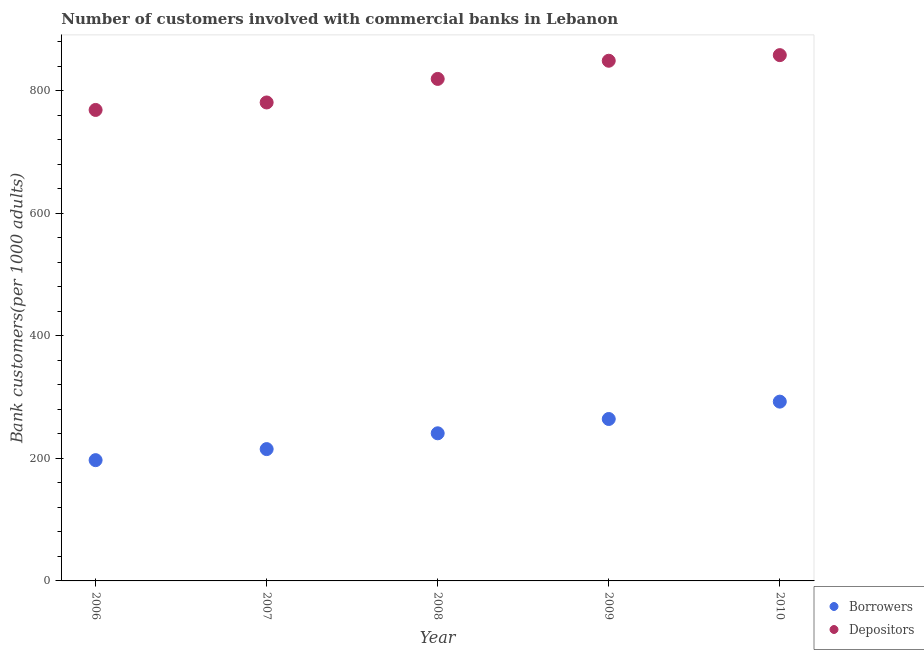Is the number of dotlines equal to the number of legend labels?
Make the answer very short. Yes. What is the number of borrowers in 2008?
Give a very brief answer. 240.91. Across all years, what is the maximum number of borrowers?
Provide a short and direct response. 292.58. Across all years, what is the minimum number of borrowers?
Offer a very short reply. 197.08. In which year was the number of depositors maximum?
Keep it short and to the point. 2010. In which year was the number of depositors minimum?
Give a very brief answer. 2006. What is the total number of borrowers in the graph?
Your answer should be very brief. 1209.93. What is the difference between the number of depositors in 2009 and that in 2010?
Your answer should be very brief. -9.17. What is the difference between the number of borrowers in 2007 and the number of depositors in 2009?
Provide a short and direct response. -633.75. What is the average number of depositors per year?
Give a very brief answer. 815.1. In the year 2006, what is the difference between the number of borrowers and number of depositors?
Offer a very short reply. -571.5. What is the ratio of the number of borrowers in 2008 to that in 2010?
Make the answer very short. 0.82. Is the number of borrowers in 2009 less than that in 2010?
Your answer should be compact. Yes. What is the difference between the highest and the second highest number of depositors?
Your response must be concise. 9.17. What is the difference between the highest and the lowest number of borrowers?
Offer a terse response. 95.5. Is the sum of the number of borrowers in 2007 and 2010 greater than the maximum number of depositors across all years?
Offer a terse response. No. Is the number of depositors strictly less than the number of borrowers over the years?
Offer a terse response. No. How many years are there in the graph?
Give a very brief answer. 5. Are the values on the major ticks of Y-axis written in scientific E-notation?
Your answer should be very brief. No. Does the graph contain grids?
Give a very brief answer. No. How many legend labels are there?
Provide a short and direct response. 2. How are the legend labels stacked?
Offer a very short reply. Vertical. What is the title of the graph?
Your answer should be compact. Number of customers involved with commercial banks in Lebanon. Does "Current education expenditure" appear as one of the legend labels in the graph?
Keep it short and to the point. No. What is the label or title of the X-axis?
Your answer should be compact. Year. What is the label or title of the Y-axis?
Give a very brief answer. Bank customers(per 1000 adults). What is the Bank customers(per 1000 adults) of Borrowers in 2006?
Provide a succinct answer. 197.08. What is the Bank customers(per 1000 adults) of Depositors in 2006?
Ensure brevity in your answer.  768.58. What is the Bank customers(per 1000 adults) of Borrowers in 2007?
Make the answer very short. 215.11. What is the Bank customers(per 1000 adults) of Depositors in 2007?
Offer a terse response. 780.78. What is the Bank customers(per 1000 adults) of Borrowers in 2008?
Provide a succinct answer. 240.91. What is the Bank customers(per 1000 adults) in Depositors in 2008?
Your answer should be compact. 819.23. What is the Bank customers(per 1000 adults) in Borrowers in 2009?
Provide a short and direct response. 264.25. What is the Bank customers(per 1000 adults) of Depositors in 2009?
Provide a short and direct response. 848.86. What is the Bank customers(per 1000 adults) in Borrowers in 2010?
Give a very brief answer. 292.58. What is the Bank customers(per 1000 adults) in Depositors in 2010?
Provide a short and direct response. 858.04. Across all years, what is the maximum Bank customers(per 1000 adults) in Borrowers?
Your response must be concise. 292.58. Across all years, what is the maximum Bank customers(per 1000 adults) of Depositors?
Ensure brevity in your answer.  858.04. Across all years, what is the minimum Bank customers(per 1000 adults) of Borrowers?
Offer a terse response. 197.08. Across all years, what is the minimum Bank customers(per 1000 adults) in Depositors?
Give a very brief answer. 768.58. What is the total Bank customers(per 1000 adults) in Borrowers in the graph?
Your response must be concise. 1209.93. What is the total Bank customers(per 1000 adults) of Depositors in the graph?
Your answer should be very brief. 4075.48. What is the difference between the Bank customers(per 1000 adults) in Borrowers in 2006 and that in 2007?
Give a very brief answer. -18.03. What is the difference between the Bank customers(per 1000 adults) in Depositors in 2006 and that in 2007?
Offer a terse response. -12.2. What is the difference between the Bank customers(per 1000 adults) in Borrowers in 2006 and that in 2008?
Make the answer very short. -43.83. What is the difference between the Bank customers(per 1000 adults) in Depositors in 2006 and that in 2008?
Your response must be concise. -50.65. What is the difference between the Bank customers(per 1000 adults) of Borrowers in 2006 and that in 2009?
Make the answer very short. -67.17. What is the difference between the Bank customers(per 1000 adults) in Depositors in 2006 and that in 2009?
Make the answer very short. -80.28. What is the difference between the Bank customers(per 1000 adults) in Borrowers in 2006 and that in 2010?
Keep it short and to the point. -95.5. What is the difference between the Bank customers(per 1000 adults) of Depositors in 2006 and that in 2010?
Offer a very short reply. -89.46. What is the difference between the Bank customers(per 1000 adults) of Borrowers in 2007 and that in 2008?
Offer a terse response. -25.79. What is the difference between the Bank customers(per 1000 adults) in Depositors in 2007 and that in 2008?
Provide a succinct answer. -38.45. What is the difference between the Bank customers(per 1000 adults) of Borrowers in 2007 and that in 2009?
Provide a short and direct response. -49.13. What is the difference between the Bank customers(per 1000 adults) in Depositors in 2007 and that in 2009?
Offer a terse response. -68.08. What is the difference between the Bank customers(per 1000 adults) of Borrowers in 2007 and that in 2010?
Offer a very short reply. -77.47. What is the difference between the Bank customers(per 1000 adults) of Depositors in 2007 and that in 2010?
Provide a short and direct response. -77.26. What is the difference between the Bank customers(per 1000 adults) of Borrowers in 2008 and that in 2009?
Keep it short and to the point. -23.34. What is the difference between the Bank customers(per 1000 adults) in Depositors in 2008 and that in 2009?
Ensure brevity in your answer.  -29.63. What is the difference between the Bank customers(per 1000 adults) in Borrowers in 2008 and that in 2010?
Offer a terse response. -51.68. What is the difference between the Bank customers(per 1000 adults) in Depositors in 2008 and that in 2010?
Your answer should be compact. -38.81. What is the difference between the Bank customers(per 1000 adults) of Borrowers in 2009 and that in 2010?
Provide a short and direct response. -28.33. What is the difference between the Bank customers(per 1000 adults) of Depositors in 2009 and that in 2010?
Make the answer very short. -9.17. What is the difference between the Bank customers(per 1000 adults) of Borrowers in 2006 and the Bank customers(per 1000 adults) of Depositors in 2007?
Your answer should be compact. -583.7. What is the difference between the Bank customers(per 1000 adults) in Borrowers in 2006 and the Bank customers(per 1000 adults) in Depositors in 2008?
Provide a succinct answer. -622.15. What is the difference between the Bank customers(per 1000 adults) of Borrowers in 2006 and the Bank customers(per 1000 adults) of Depositors in 2009?
Make the answer very short. -651.78. What is the difference between the Bank customers(per 1000 adults) in Borrowers in 2006 and the Bank customers(per 1000 adults) in Depositors in 2010?
Your answer should be very brief. -660.96. What is the difference between the Bank customers(per 1000 adults) in Borrowers in 2007 and the Bank customers(per 1000 adults) in Depositors in 2008?
Ensure brevity in your answer.  -604.11. What is the difference between the Bank customers(per 1000 adults) of Borrowers in 2007 and the Bank customers(per 1000 adults) of Depositors in 2009?
Offer a very short reply. -633.75. What is the difference between the Bank customers(per 1000 adults) of Borrowers in 2007 and the Bank customers(per 1000 adults) of Depositors in 2010?
Provide a succinct answer. -642.92. What is the difference between the Bank customers(per 1000 adults) in Borrowers in 2008 and the Bank customers(per 1000 adults) in Depositors in 2009?
Your answer should be very brief. -607.96. What is the difference between the Bank customers(per 1000 adults) of Borrowers in 2008 and the Bank customers(per 1000 adults) of Depositors in 2010?
Provide a short and direct response. -617.13. What is the difference between the Bank customers(per 1000 adults) of Borrowers in 2009 and the Bank customers(per 1000 adults) of Depositors in 2010?
Make the answer very short. -593.79. What is the average Bank customers(per 1000 adults) of Borrowers per year?
Offer a very short reply. 241.99. What is the average Bank customers(per 1000 adults) in Depositors per year?
Your answer should be compact. 815.1. In the year 2006, what is the difference between the Bank customers(per 1000 adults) of Borrowers and Bank customers(per 1000 adults) of Depositors?
Ensure brevity in your answer.  -571.5. In the year 2007, what is the difference between the Bank customers(per 1000 adults) of Borrowers and Bank customers(per 1000 adults) of Depositors?
Your answer should be very brief. -565.67. In the year 2008, what is the difference between the Bank customers(per 1000 adults) of Borrowers and Bank customers(per 1000 adults) of Depositors?
Provide a succinct answer. -578.32. In the year 2009, what is the difference between the Bank customers(per 1000 adults) in Borrowers and Bank customers(per 1000 adults) in Depositors?
Provide a succinct answer. -584.61. In the year 2010, what is the difference between the Bank customers(per 1000 adults) in Borrowers and Bank customers(per 1000 adults) in Depositors?
Ensure brevity in your answer.  -565.45. What is the ratio of the Bank customers(per 1000 adults) in Borrowers in 2006 to that in 2007?
Keep it short and to the point. 0.92. What is the ratio of the Bank customers(per 1000 adults) in Depositors in 2006 to that in 2007?
Provide a short and direct response. 0.98. What is the ratio of the Bank customers(per 1000 adults) of Borrowers in 2006 to that in 2008?
Offer a terse response. 0.82. What is the ratio of the Bank customers(per 1000 adults) of Depositors in 2006 to that in 2008?
Provide a short and direct response. 0.94. What is the ratio of the Bank customers(per 1000 adults) of Borrowers in 2006 to that in 2009?
Ensure brevity in your answer.  0.75. What is the ratio of the Bank customers(per 1000 adults) in Depositors in 2006 to that in 2009?
Offer a terse response. 0.91. What is the ratio of the Bank customers(per 1000 adults) in Borrowers in 2006 to that in 2010?
Your response must be concise. 0.67. What is the ratio of the Bank customers(per 1000 adults) in Depositors in 2006 to that in 2010?
Provide a succinct answer. 0.9. What is the ratio of the Bank customers(per 1000 adults) in Borrowers in 2007 to that in 2008?
Your response must be concise. 0.89. What is the ratio of the Bank customers(per 1000 adults) in Depositors in 2007 to that in 2008?
Your answer should be compact. 0.95. What is the ratio of the Bank customers(per 1000 adults) of Borrowers in 2007 to that in 2009?
Your response must be concise. 0.81. What is the ratio of the Bank customers(per 1000 adults) in Depositors in 2007 to that in 2009?
Your answer should be very brief. 0.92. What is the ratio of the Bank customers(per 1000 adults) in Borrowers in 2007 to that in 2010?
Provide a succinct answer. 0.74. What is the ratio of the Bank customers(per 1000 adults) of Depositors in 2007 to that in 2010?
Your response must be concise. 0.91. What is the ratio of the Bank customers(per 1000 adults) in Borrowers in 2008 to that in 2009?
Offer a terse response. 0.91. What is the ratio of the Bank customers(per 1000 adults) in Depositors in 2008 to that in 2009?
Your response must be concise. 0.97. What is the ratio of the Bank customers(per 1000 adults) of Borrowers in 2008 to that in 2010?
Ensure brevity in your answer.  0.82. What is the ratio of the Bank customers(per 1000 adults) in Depositors in 2008 to that in 2010?
Make the answer very short. 0.95. What is the ratio of the Bank customers(per 1000 adults) of Borrowers in 2009 to that in 2010?
Your answer should be very brief. 0.9. What is the ratio of the Bank customers(per 1000 adults) in Depositors in 2009 to that in 2010?
Offer a terse response. 0.99. What is the difference between the highest and the second highest Bank customers(per 1000 adults) of Borrowers?
Provide a succinct answer. 28.33. What is the difference between the highest and the second highest Bank customers(per 1000 adults) of Depositors?
Ensure brevity in your answer.  9.17. What is the difference between the highest and the lowest Bank customers(per 1000 adults) of Borrowers?
Make the answer very short. 95.5. What is the difference between the highest and the lowest Bank customers(per 1000 adults) in Depositors?
Your answer should be very brief. 89.46. 